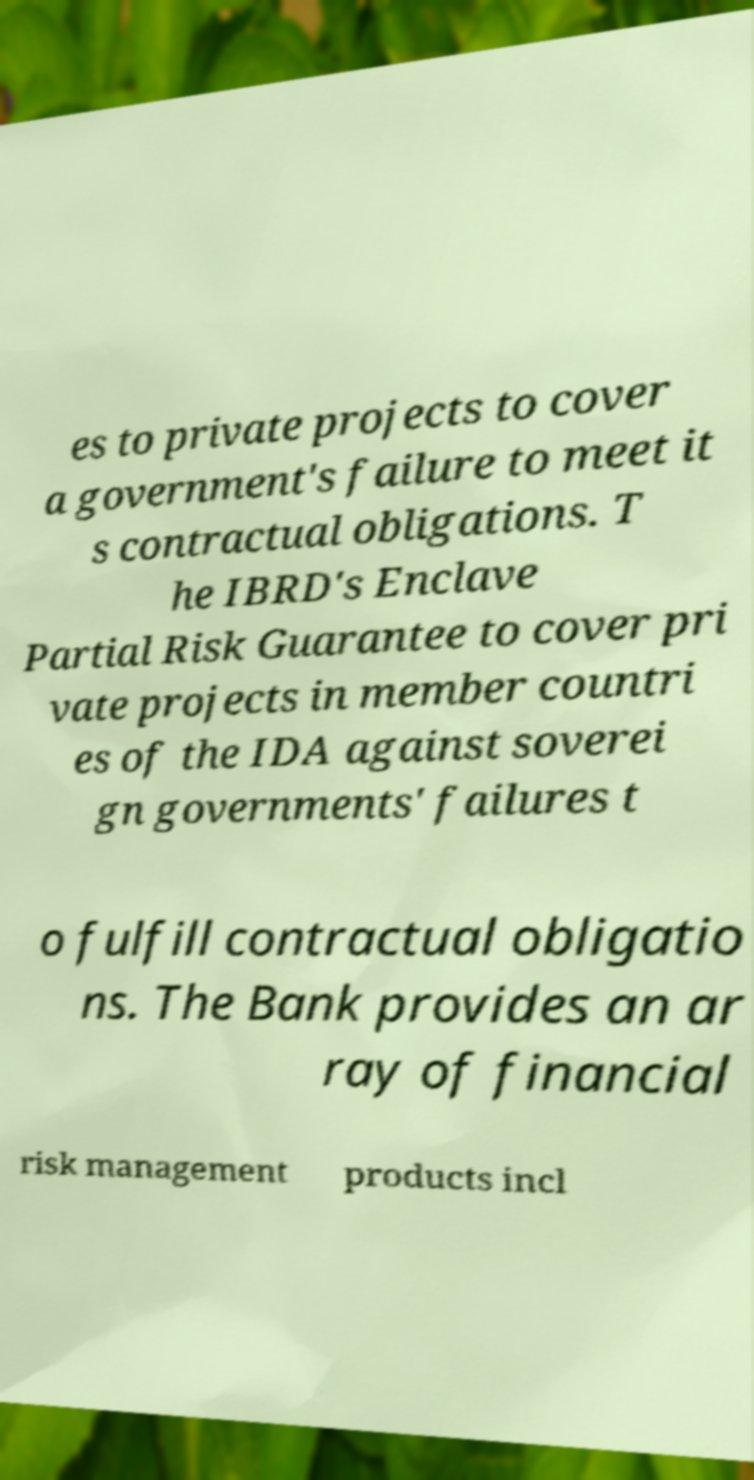Please read and relay the text visible in this image. What does it say? es to private projects to cover a government's failure to meet it s contractual obligations. T he IBRD's Enclave Partial Risk Guarantee to cover pri vate projects in member countri es of the IDA against soverei gn governments' failures t o fulfill contractual obligatio ns. The Bank provides an ar ray of financial risk management products incl 